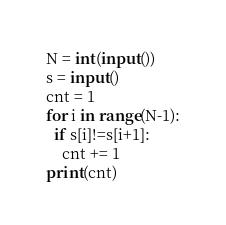<code> <loc_0><loc_0><loc_500><loc_500><_Python_>N = int(input())
s = input()
cnt = 1
for i in range(N-1):
  if s[i]!=s[i+1]:
    cnt += 1
print(cnt)</code> 